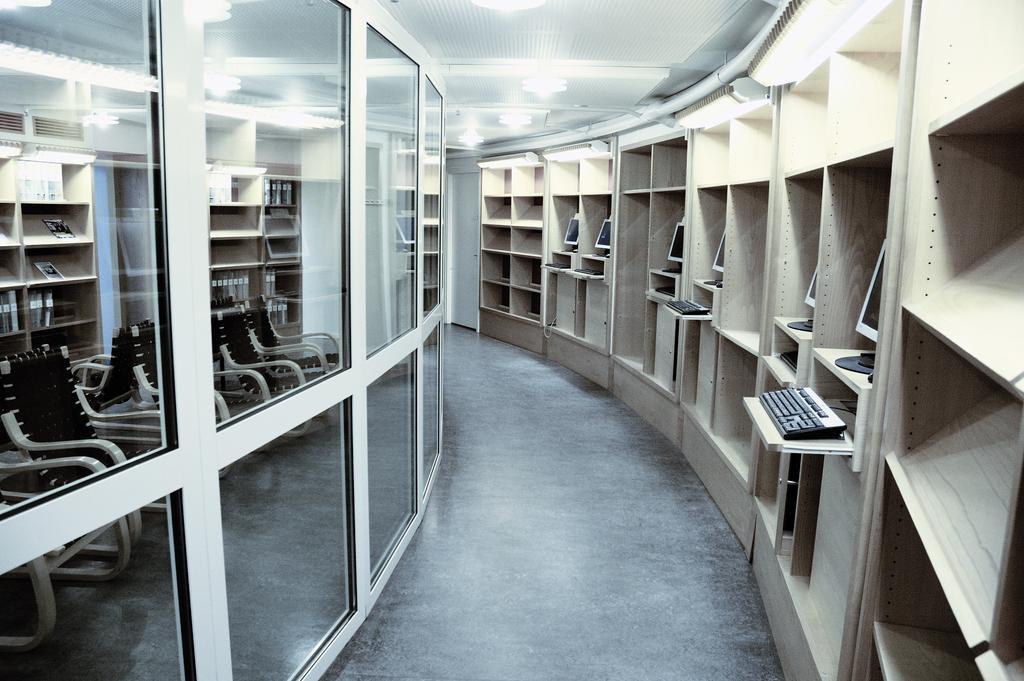Describe this image in one or two sentences. In this picture we can see the floor, monitors, keyboards, racks, chairs, glass and some objects and in the background we can see the lights, ceiling. 